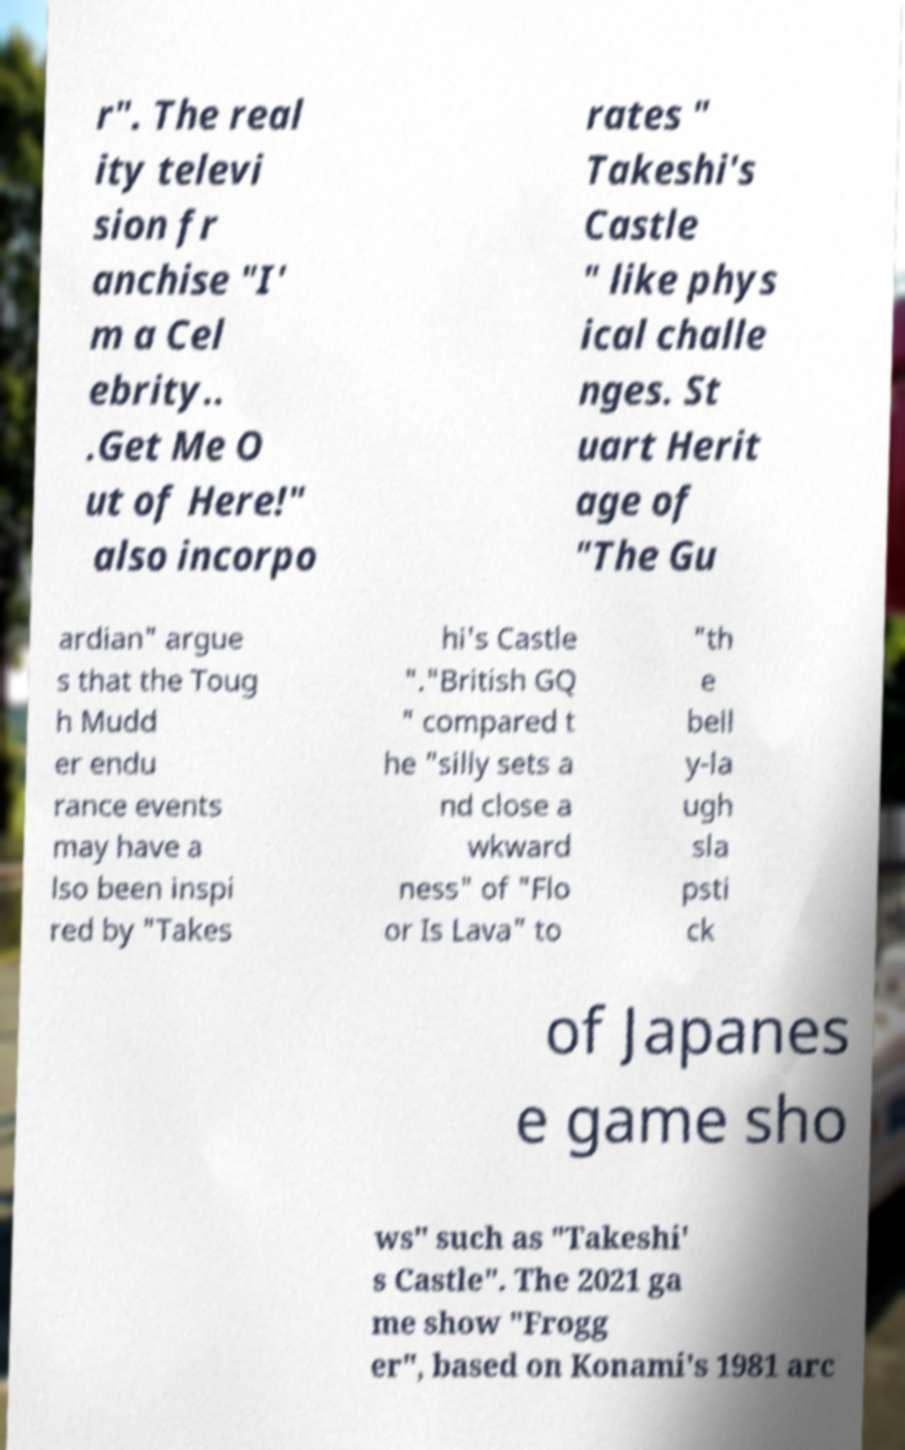What messages or text are displayed in this image? I need them in a readable, typed format. r". The real ity televi sion fr anchise "I' m a Cel ebrity.. .Get Me O ut of Here!" also incorpo rates " Takeshi's Castle " like phys ical challe nges. St uart Herit age of "The Gu ardian" argue s that the Toug h Mudd er endu rance events may have a lso been inspi red by "Takes hi's Castle "."British GQ " compared t he "silly sets a nd close a wkward ness" of "Flo or Is Lava" to "th e bell y-la ugh sla psti ck of Japanes e game sho ws" such as "Takeshi' s Castle". The 2021 ga me show "Frogg er", based on Konami's 1981 arc 